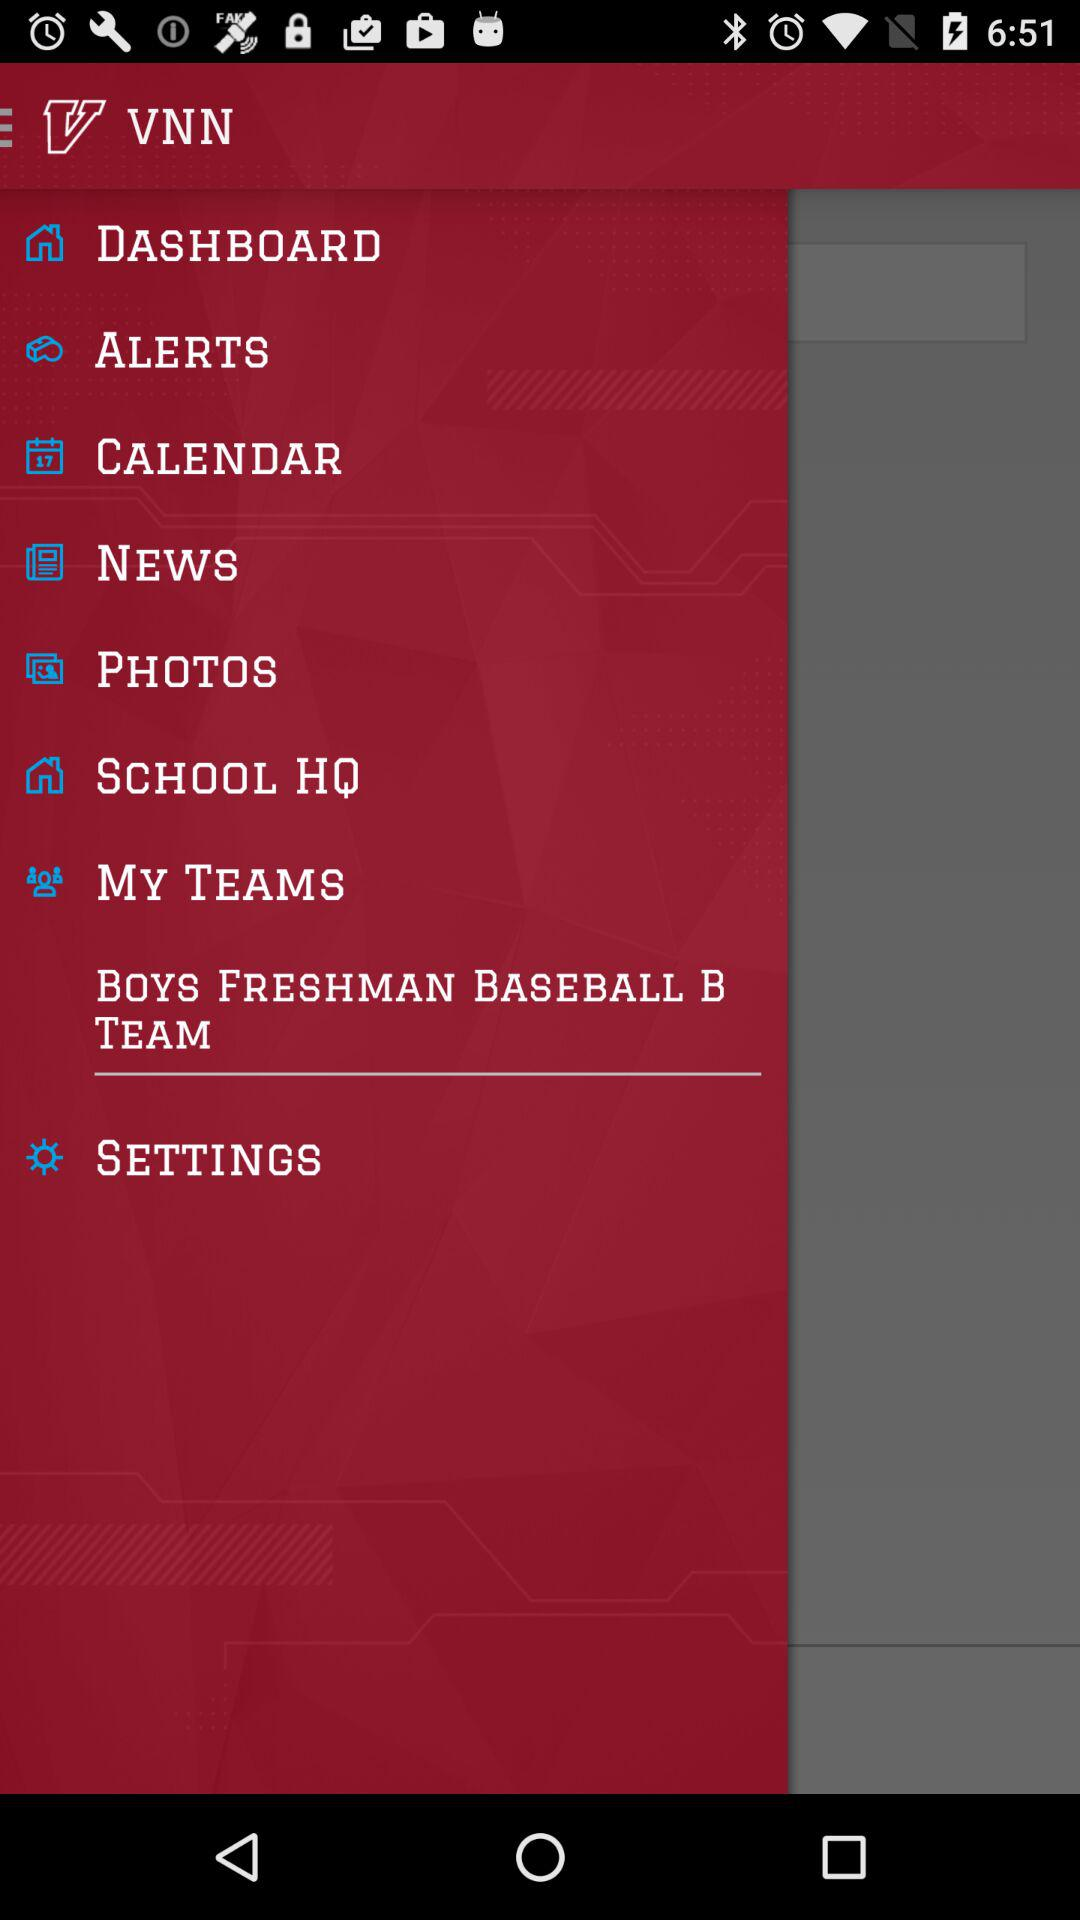What is the app name? The app name is "VNN". 